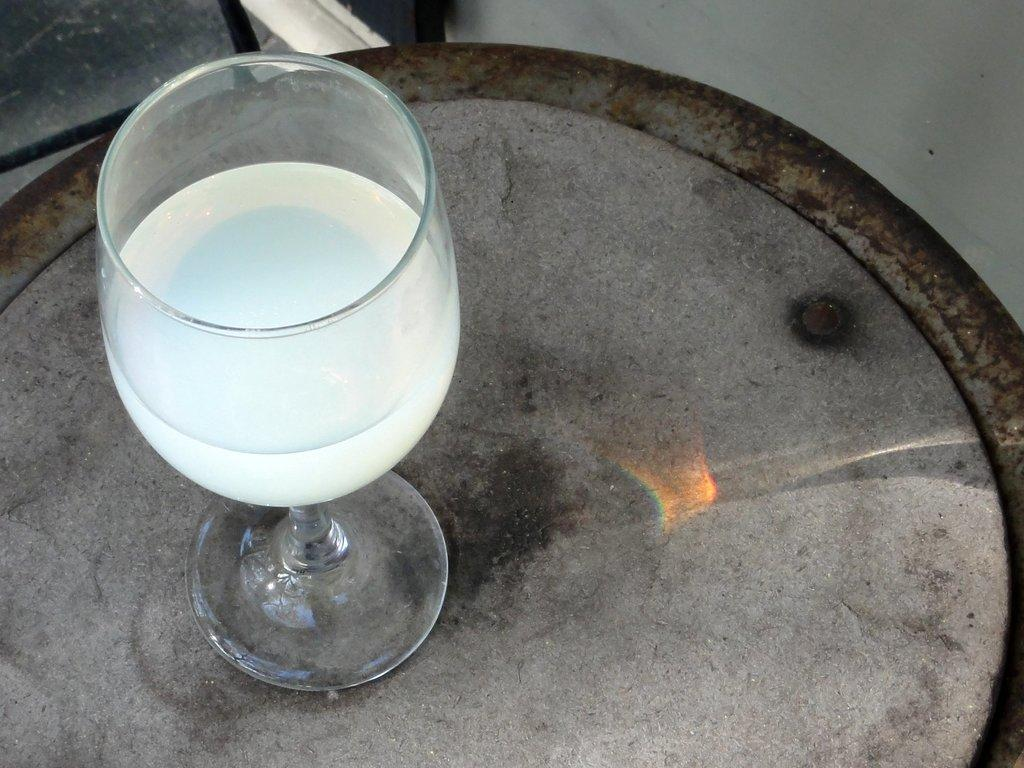What is contained in the tumbler in the image? There is a beverage in a tumbler. Where is the tumbler located in the image? The tumbler is placed on a table. Are there any fairies visible in the image? There are no fairies present in the image. What type of war is depicted in the image? There is no depiction of war in the image; it only features a beverage in a tumbler placed on a table. 